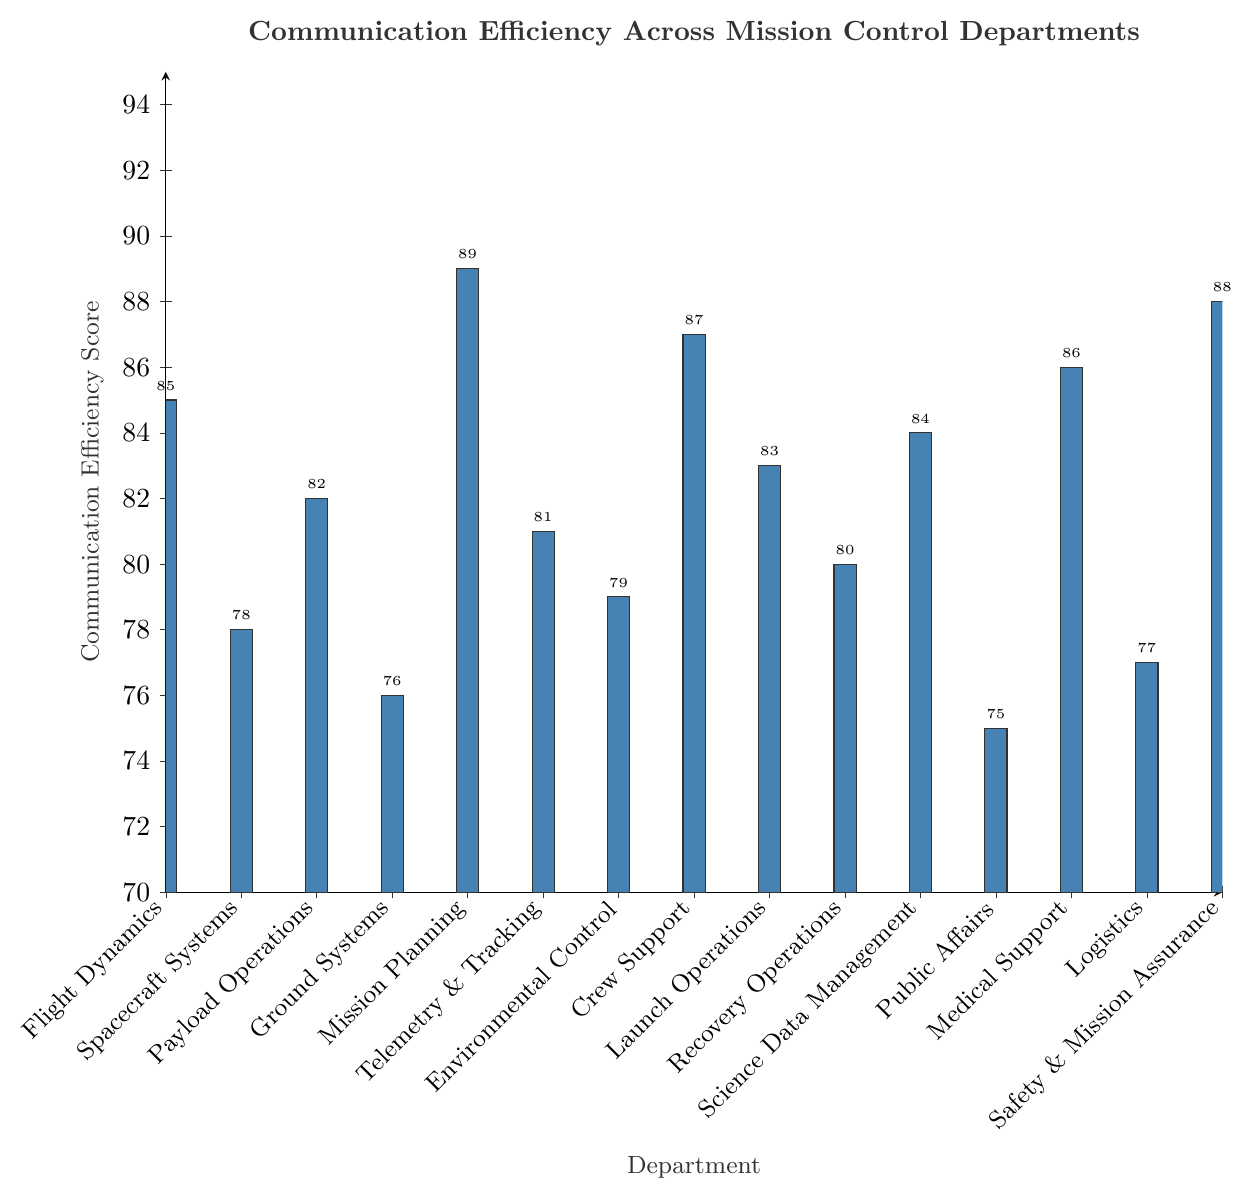Which department has the highest communication efficiency score? Look for the bar with the greatest height on the figure. The tallest bar is for the Mission Planning department with a score of 89.
Answer: Mission Planning Which departments have communication efficiency scores above 85? Identify the bars with scores higher than 85. The bars for Safety & Mission Assurance (88), Crew Support (87), Medical Support (86), and Flight Dynamics (85) fall into this range.
Answer: Safety & Mission Assurance, Crew Support, Medical Support What is the difference in communication efficiency score between Mission Planning and Public Affairs? Subtract the score of Public Affairs from the score of Mission Planning (89 - 75).
Answer: 14 Which department has the lowest communication efficiency score? Look for the bar with the smallest height on the figure. The shortest bar corresponds to the Public Affairs department with a score of 75.
Answer: Public Affairs Is the communication efficiency score of Crew Support greater than or equal to that of Spacecraft Systems? Compare the heights of the Crew Support and Spacecraft Systems bars. Crew Support has a score of 87, while Spacecraft Systems has a score of 78, so yes, Crew Support's score is greater.
Answer: Yes What is the total communication efficiency score of the Science Data Management, Recovery Operations, and Payload Operations departments combined? Sum the scores: 84 (Science Data Management) + 80 (Recovery Operations) + 82 (Payload Operations).
Answer: 246 Which departments have scores less than 80? Identify the bars with scores lower than 80. These include Public Affairs (75), Ground Systems (76), Logistics (77), and Spacecraft Systems (78).
Answer: Public Affairs, Ground Systems, Logistics, Spacecraft Systems How many departments have a communication efficiency score between 80 and 85 inclusive? Count the bars with scores within the range of 80 to 85. These departments are Telemetry & Tracking, Recovery Operations, Launch Operations, Science Data Management, and Flight Dynamics, making it 5 departments.
Answer: 5 